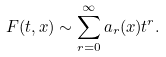<formula> <loc_0><loc_0><loc_500><loc_500>F ( t , x ) \sim \sum _ { r = 0 } ^ { \infty } a _ { r } ( x ) t ^ { r } .</formula> 